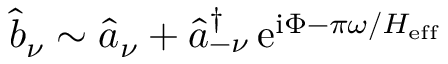Convert formula to latex. <formula><loc_0><loc_0><loc_500><loc_500>\widehat { b } _ { \nu } \sim \widehat { a } _ { \nu } + \widehat { a } _ { - \nu } ^ { \dagger } \, e ^ { i \Phi - \pi \omega / H _ { e f f } }</formula> 